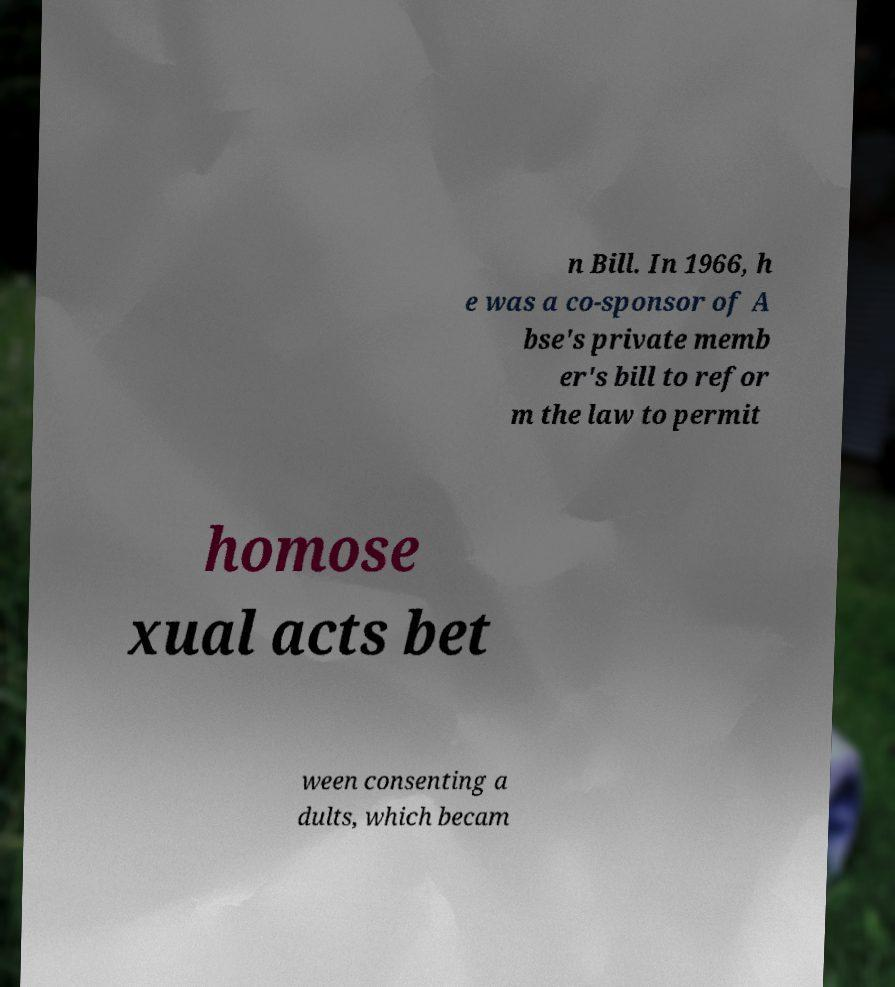Please identify and transcribe the text found in this image. n Bill. In 1966, h e was a co-sponsor of A bse's private memb er's bill to refor m the law to permit homose xual acts bet ween consenting a dults, which becam 